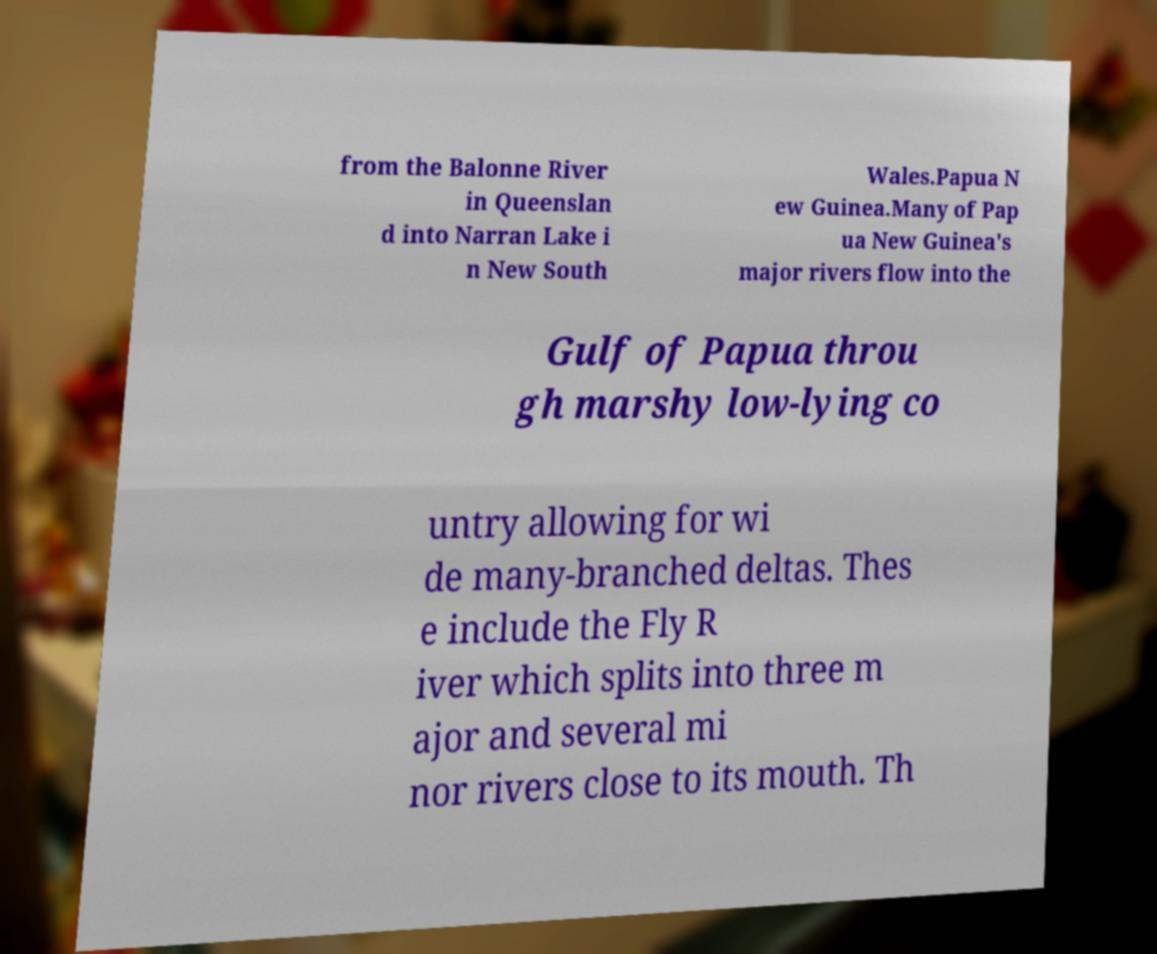There's text embedded in this image that I need extracted. Can you transcribe it verbatim? from the Balonne River in Queenslan d into Narran Lake i n New South Wales.Papua N ew Guinea.Many of Pap ua New Guinea's major rivers flow into the Gulf of Papua throu gh marshy low-lying co untry allowing for wi de many-branched deltas. Thes e include the Fly R iver which splits into three m ajor and several mi nor rivers close to its mouth. Th 